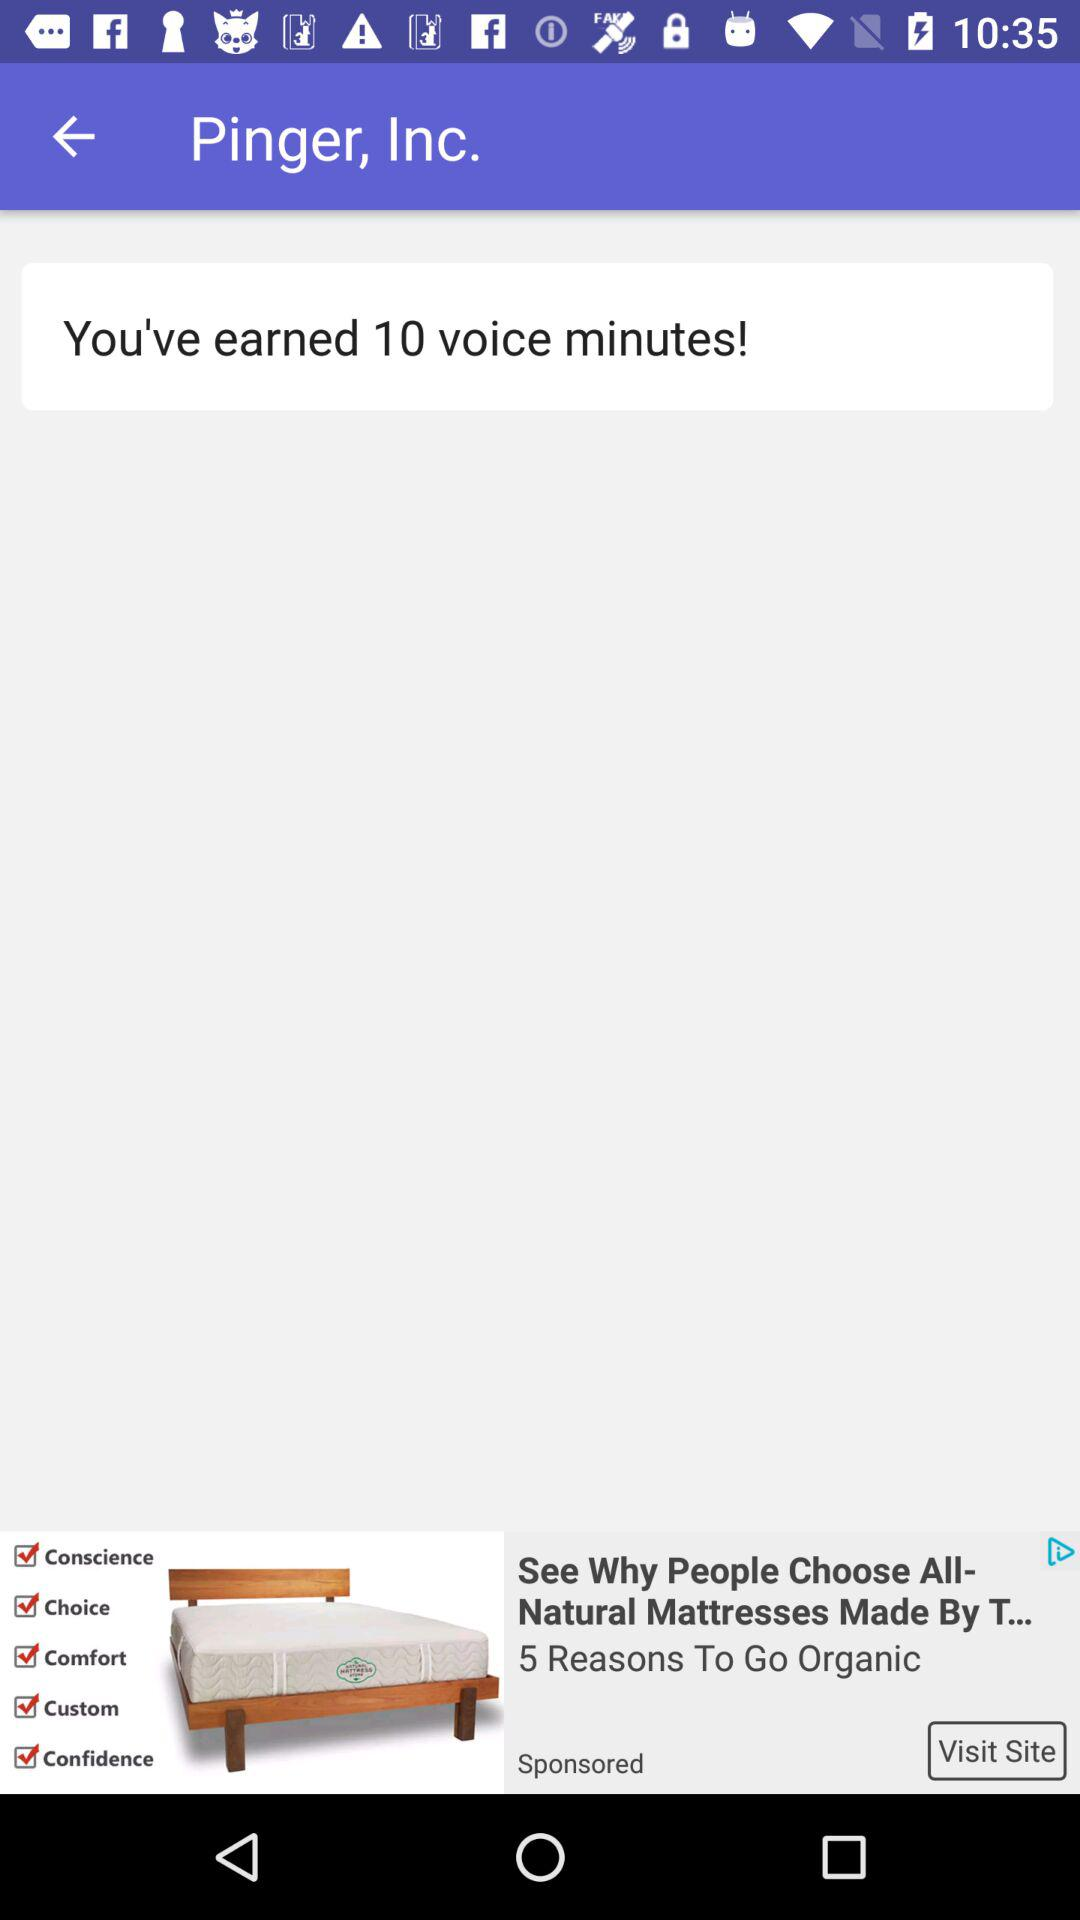How many voice minutes have we earned? You have earned 10 voice minutes. 